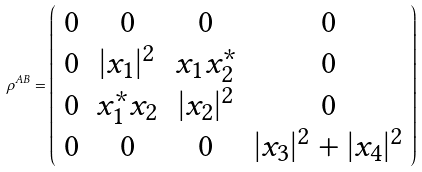<formula> <loc_0><loc_0><loc_500><loc_500>\rho ^ { A B } = \left ( \begin{array} { c c c c } 0 & 0 & 0 & 0 \\ 0 & | x _ { 1 } | ^ { 2 } & x _ { 1 } x ^ { * } _ { 2 } & 0 \\ 0 & x _ { 1 } ^ { * } x _ { 2 } & | x _ { 2 } | ^ { 2 } & 0 \\ 0 & 0 & 0 & | x _ { 3 } | ^ { 2 } + | x _ { 4 } | ^ { 2 } \\ \end{array} \right )</formula> 